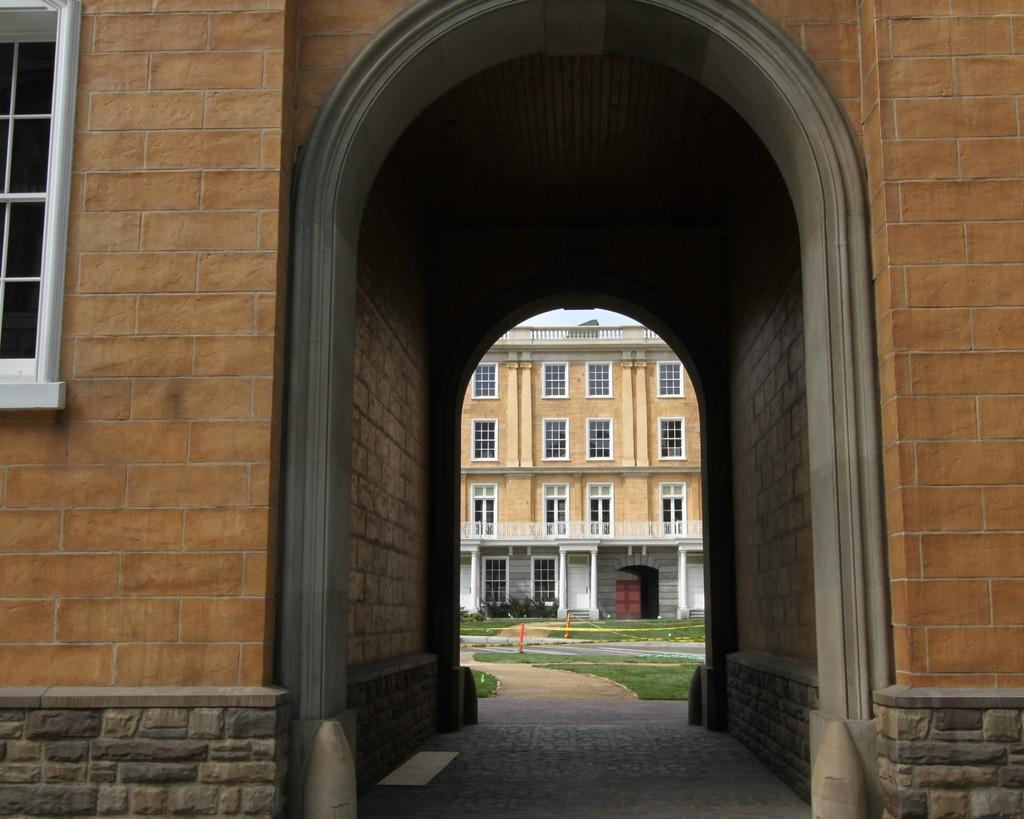What type of structures can be seen in the image? There are buildings in the image. What type of natural environment is visible in the image? There is grass visible in the image. What type of crack is present in the image? There is no crack present in the image. What type of apparel is being worn by the grass in the image? The grass in the image is not wearing any apparel, as it is a natural environment. 